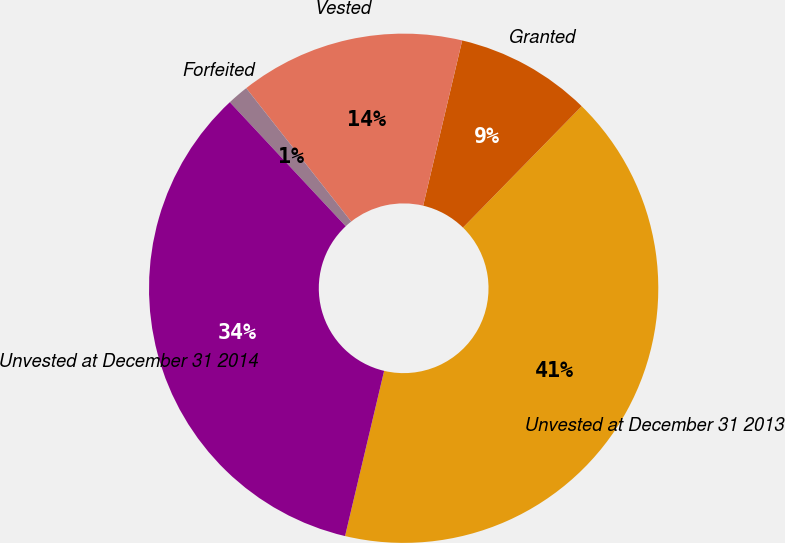Convert chart. <chart><loc_0><loc_0><loc_500><loc_500><pie_chart><fcel>Unvested at December 31 2013<fcel>Granted<fcel>Vested<fcel>Forfeited<fcel>Unvested at December 31 2014<nl><fcel>41.37%<fcel>8.63%<fcel>14.3%<fcel>1.35%<fcel>34.34%<nl></chart> 